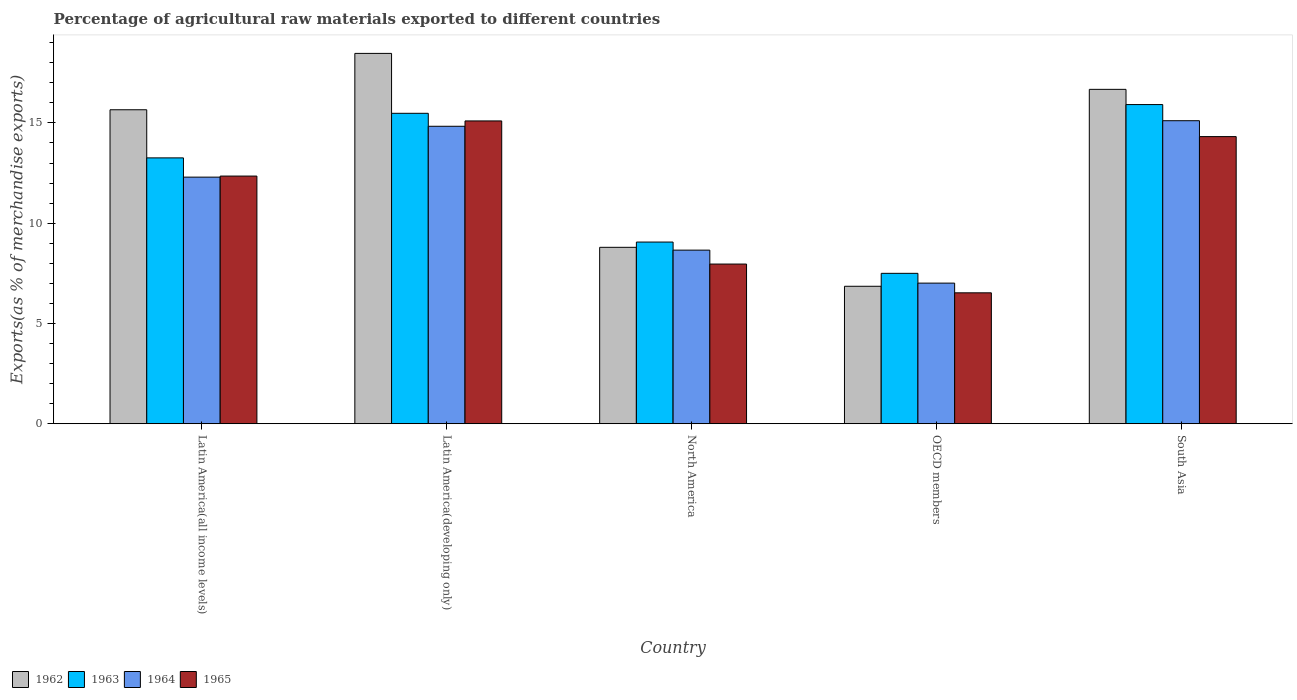How many different coloured bars are there?
Keep it short and to the point. 4. Are the number of bars per tick equal to the number of legend labels?
Your response must be concise. Yes. Are the number of bars on each tick of the X-axis equal?
Provide a succinct answer. Yes. How many bars are there on the 1st tick from the left?
Provide a succinct answer. 4. What is the label of the 2nd group of bars from the left?
Your answer should be very brief. Latin America(developing only). What is the percentage of exports to different countries in 1964 in OECD members?
Ensure brevity in your answer.  7.01. Across all countries, what is the maximum percentage of exports to different countries in 1964?
Offer a very short reply. 15.11. Across all countries, what is the minimum percentage of exports to different countries in 1965?
Your response must be concise. 6.53. In which country was the percentage of exports to different countries in 1964 maximum?
Provide a succinct answer. South Asia. In which country was the percentage of exports to different countries in 1963 minimum?
Provide a short and direct response. OECD members. What is the total percentage of exports to different countries in 1965 in the graph?
Ensure brevity in your answer.  56.26. What is the difference between the percentage of exports to different countries in 1965 in Latin America(developing only) and that in South Asia?
Make the answer very short. 0.78. What is the difference between the percentage of exports to different countries in 1965 in Latin America(all income levels) and the percentage of exports to different countries in 1964 in North America?
Your response must be concise. 3.69. What is the average percentage of exports to different countries in 1962 per country?
Make the answer very short. 13.29. What is the difference between the percentage of exports to different countries of/in 1965 and percentage of exports to different countries of/in 1964 in Latin America(all income levels)?
Your response must be concise. 0.05. In how many countries, is the percentage of exports to different countries in 1962 greater than 9 %?
Your answer should be very brief. 3. What is the ratio of the percentage of exports to different countries in 1965 in Latin America(all income levels) to that in South Asia?
Your answer should be very brief. 0.86. What is the difference between the highest and the second highest percentage of exports to different countries in 1964?
Keep it short and to the point. -2.54. What is the difference between the highest and the lowest percentage of exports to different countries in 1962?
Ensure brevity in your answer.  11.61. Is it the case that in every country, the sum of the percentage of exports to different countries in 1965 and percentage of exports to different countries in 1964 is greater than the sum of percentage of exports to different countries in 1962 and percentage of exports to different countries in 1963?
Offer a terse response. No. What does the 4th bar from the left in North America represents?
Ensure brevity in your answer.  1965. What does the 1st bar from the right in North America represents?
Offer a very short reply. 1965. Are all the bars in the graph horizontal?
Ensure brevity in your answer.  No. How many countries are there in the graph?
Keep it short and to the point. 5. Does the graph contain any zero values?
Your response must be concise. No. Does the graph contain grids?
Make the answer very short. No. How are the legend labels stacked?
Make the answer very short. Horizontal. What is the title of the graph?
Keep it short and to the point. Percentage of agricultural raw materials exported to different countries. What is the label or title of the X-axis?
Ensure brevity in your answer.  Country. What is the label or title of the Y-axis?
Your response must be concise. Exports(as % of merchandise exports). What is the Exports(as % of merchandise exports) in 1962 in Latin America(all income levels)?
Make the answer very short. 15.66. What is the Exports(as % of merchandise exports) of 1963 in Latin America(all income levels)?
Offer a very short reply. 13.26. What is the Exports(as % of merchandise exports) in 1964 in Latin America(all income levels)?
Ensure brevity in your answer.  12.3. What is the Exports(as % of merchandise exports) in 1965 in Latin America(all income levels)?
Make the answer very short. 12.35. What is the Exports(as % of merchandise exports) in 1962 in Latin America(developing only)?
Give a very brief answer. 18.47. What is the Exports(as % of merchandise exports) of 1963 in Latin America(developing only)?
Your response must be concise. 15.48. What is the Exports(as % of merchandise exports) of 1964 in Latin America(developing only)?
Give a very brief answer. 14.83. What is the Exports(as % of merchandise exports) in 1965 in Latin America(developing only)?
Offer a terse response. 15.1. What is the Exports(as % of merchandise exports) in 1962 in North America?
Provide a short and direct response. 8.8. What is the Exports(as % of merchandise exports) in 1963 in North America?
Provide a succinct answer. 9.06. What is the Exports(as % of merchandise exports) of 1964 in North America?
Provide a succinct answer. 8.66. What is the Exports(as % of merchandise exports) in 1965 in North America?
Your response must be concise. 7.96. What is the Exports(as % of merchandise exports) in 1962 in OECD members?
Make the answer very short. 6.85. What is the Exports(as % of merchandise exports) in 1963 in OECD members?
Provide a succinct answer. 7.5. What is the Exports(as % of merchandise exports) in 1964 in OECD members?
Your response must be concise. 7.01. What is the Exports(as % of merchandise exports) of 1965 in OECD members?
Give a very brief answer. 6.53. What is the Exports(as % of merchandise exports) of 1962 in South Asia?
Your response must be concise. 16.67. What is the Exports(as % of merchandise exports) in 1963 in South Asia?
Offer a terse response. 15.92. What is the Exports(as % of merchandise exports) of 1964 in South Asia?
Offer a terse response. 15.11. What is the Exports(as % of merchandise exports) in 1965 in South Asia?
Give a very brief answer. 14.32. Across all countries, what is the maximum Exports(as % of merchandise exports) in 1962?
Give a very brief answer. 18.47. Across all countries, what is the maximum Exports(as % of merchandise exports) of 1963?
Make the answer very short. 15.92. Across all countries, what is the maximum Exports(as % of merchandise exports) in 1964?
Offer a terse response. 15.11. Across all countries, what is the maximum Exports(as % of merchandise exports) of 1965?
Provide a short and direct response. 15.1. Across all countries, what is the minimum Exports(as % of merchandise exports) in 1962?
Provide a succinct answer. 6.85. Across all countries, what is the minimum Exports(as % of merchandise exports) of 1963?
Keep it short and to the point. 7.5. Across all countries, what is the minimum Exports(as % of merchandise exports) of 1964?
Your answer should be compact. 7.01. Across all countries, what is the minimum Exports(as % of merchandise exports) in 1965?
Ensure brevity in your answer.  6.53. What is the total Exports(as % of merchandise exports) of 1962 in the graph?
Offer a terse response. 66.45. What is the total Exports(as % of merchandise exports) in 1963 in the graph?
Offer a very short reply. 61.21. What is the total Exports(as % of merchandise exports) of 1964 in the graph?
Give a very brief answer. 57.91. What is the total Exports(as % of merchandise exports) of 1965 in the graph?
Make the answer very short. 56.26. What is the difference between the Exports(as % of merchandise exports) of 1962 in Latin America(all income levels) and that in Latin America(developing only)?
Give a very brief answer. -2.81. What is the difference between the Exports(as % of merchandise exports) of 1963 in Latin America(all income levels) and that in Latin America(developing only)?
Provide a succinct answer. -2.22. What is the difference between the Exports(as % of merchandise exports) of 1964 in Latin America(all income levels) and that in Latin America(developing only)?
Your response must be concise. -2.54. What is the difference between the Exports(as % of merchandise exports) of 1965 in Latin America(all income levels) and that in Latin America(developing only)?
Keep it short and to the point. -2.75. What is the difference between the Exports(as % of merchandise exports) in 1962 in Latin America(all income levels) and that in North America?
Provide a succinct answer. 6.86. What is the difference between the Exports(as % of merchandise exports) of 1963 in Latin America(all income levels) and that in North America?
Keep it short and to the point. 4.2. What is the difference between the Exports(as % of merchandise exports) of 1964 in Latin America(all income levels) and that in North America?
Keep it short and to the point. 3.64. What is the difference between the Exports(as % of merchandise exports) in 1965 in Latin America(all income levels) and that in North America?
Offer a terse response. 4.39. What is the difference between the Exports(as % of merchandise exports) of 1962 in Latin America(all income levels) and that in OECD members?
Ensure brevity in your answer.  8.8. What is the difference between the Exports(as % of merchandise exports) in 1963 in Latin America(all income levels) and that in OECD members?
Ensure brevity in your answer.  5.76. What is the difference between the Exports(as % of merchandise exports) in 1964 in Latin America(all income levels) and that in OECD members?
Your response must be concise. 5.29. What is the difference between the Exports(as % of merchandise exports) in 1965 in Latin America(all income levels) and that in OECD members?
Offer a very short reply. 5.82. What is the difference between the Exports(as % of merchandise exports) of 1962 in Latin America(all income levels) and that in South Asia?
Your answer should be very brief. -1.02. What is the difference between the Exports(as % of merchandise exports) of 1963 in Latin America(all income levels) and that in South Asia?
Provide a succinct answer. -2.66. What is the difference between the Exports(as % of merchandise exports) of 1964 in Latin America(all income levels) and that in South Asia?
Make the answer very short. -2.81. What is the difference between the Exports(as % of merchandise exports) of 1965 in Latin America(all income levels) and that in South Asia?
Offer a very short reply. -1.97. What is the difference between the Exports(as % of merchandise exports) in 1962 in Latin America(developing only) and that in North America?
Your response must be concise. 9.67. What is the difference between the Exports(as % of merchandise exports) of 1963 in Latin America(developing only) and that in North America?
Make the answer very short. 6.42. What is the difference between the Exports(as % of merchandise exports) of 1964 in Latin America(developing only) and that in North America?
Keep it short and to the point. 6.18. What is the difference between the Exports(as % of merchandise exports) of 1965 in Latin America(developing only) and that in North America?
Make the answer very short. 7.14. What is the difference between the Exports(as % of merchandise exports) in 1962 in Latin America(developing only) and that in OECD members?
Offer a very short reply. 11.61. What is the difference between the Exports(as % of merchandise exports) of 1963 in Latin America(developing only) and that in OECD members?
Ensure brevity in your answer.  7.98. What is the difference between the Exports(as % of merchandise exports) in 1964 in Latin America(developing only) and that in OECD members?
Ensure brevity in your answer.  7.82. What is the difference between the Exports(as % of merchandise exports) of 1965 in Latin America(developing only) and that in OECD members?
Provide a short and direct response. 8.57. What is the difference between the Exports(as % of merchandise exports) of 1962 in Latin America(developing only) and that in South Asia?
Make the answer very short. 1.79. What is the difference between the Exports(as % of merchandise exports) in 1963 in Latin America(developing only) and that in South Asia?
Your answer should be compact. -0.44. What is the difference between the Exports(as % of merchandise exports) of 1964 in Latin America(developing only) and that in South Asia?
Make the answer very short. -0.28. What is the difference between the Exports(as % of merchandise exports) in 1965 in Latin America(developing only) and that in South Asia?
Keep it short and to the point. 0.78. What is the difference between the Exports(as % of merchandise exports) in 1962 in North America and that in OECD members?
Your response must be concise. 1.94. What is the difference between the Exports(as % of merchandise exports) in 1963 in North America and that in OECD members?
Your answer should be compact. 1.56. What is the difference between the Exports(as % of merchandise exports) in 1964 in North America and that in OECD members?
Give a very brief answer. 1.65. What is the difference between the Exports(as % of merchandise exports) in 1965 in North America and that in OECD members?
Ensure brevity in your answer.  1.43. What is the difference between the Exports(as % of merchandise exports) of 1962 in North America and that in South Asia?
Keep it short and to the point. -7.88. What is the difference between the Exports(as % of merchandise exports) in 1963 in North America and that in South Asia?
Offer a very short reply. -6.86. What is the difference between the Exports(as % of merchandise exports) in 1964 in North America and that in South Asia?
Offer a terse response. -6.45. What is the difference between the Exports(as % of merchandise exports) of 1965 in North America and that in South Asia?
Your answer should be very brief. -6.36. What is the difference between the Exports(as % of merchandise exports) of 1962 in OECD members and that in South Asia?
Keep it short and to the point. -9.82. What is the difference between the Exports(as % of merchandise exports) of 1963 in OECD members and that in South Asia?
Your answer should be compact. -8.42. What is the difference between the Exports(as % of merchandise exports) in 1964 in OECD members and that in South Asia?
Give a very brief answer. -8.1. What is the difference between the Exports(as % of merchandise exports) of 1965 in OECD members and that in South Asia?
Keep it short and to the point. -7.79. What is the difference between the Exports(as % of merchandise exports) of 1962 in Latin America(all income levels) and the Exports(as % of merchandise exports) of 1963 in Latin America(developing only)?
Provide a succinct answer. 0.18. What is the difference between the Exports(as % of merchandise exports) of 1962 in Latin America(all income levels) and the Exports(as % of merchandise exports) of 1964 in Latin America(developing only)?
Make the answer very short. 0.82. What is the difference between the Exports(as % of merchandise exports) of 1962 in Latin America(all income levels) and the Exports(as % of merchandise exports) of 1965 in Latin America(developing only)?
Your answer should be very brief. 0.56. What is the difference between the Exports(as % of merchandise exports) of 1963 in Latin America(all income levels) and the Exports(as % of merchandise exports) of 1964 in Latin America(developing only)?
Make the answer very short. -1.58. What is the difference between the Exports(as % of merchandise exports) of 1963 in Latin America(all income levels) and the Exports(as % of merchandise exports) of 1965 in Latin America(developing only)?
Offer a terse response. -1.84. What is the difference between the Exports(as % of merchandise exports) in 1964 in Latin America(all income levels) and the Exports(as % of merchandise exports) in 1965 in Latin America(developing only)?
Provide a short and direct response. -2.8. What is the difference between the Exports(as % of merchandise exports) in 1962 in Latin America(all income levels) and the Exports(as % of merchandise exports) in 1963 in North America?
Ensure brevity in your answer.  6.6. What is the difference between the Exports(as % of merchandise exports) in 1962 in Latin America(all income levels) and the Exports(as % of merchandise exports) in 1964 in North America?
Offer a terse response. 7. What is the difference between the Exports(as % of merchandise exports) of 1962 in Latin America(all income levels) and the Exports(as % of merchandise exports) of 1965 in North America?
Provide a short and direct response. 7.69. What is the difference between the Exports(as % of merchandise exports) in 1963 in Latin America(all income levels) and the Exports(as % of merchandise exports) in 1965 in North America?
Your answer should be very brief. 5.29. What is the difference between the Exports(as % of merchandise exports) of 1964 in Latin America(all income levels) and the Exports(as % of merchandise exports) of 1965 in North America?
Give a very brief answer. 4.33. What is the difference between the Exports(as % of merchandise exports) in 1962 in Latin America(all income levels) and the Exports(as % of merchandise exports) in 1963 in OECD members?
Your answer should be compact. 8.16. What is the difference between the Exports(as % of merchandise exports) of 1962 in Latin America(all income levels) and the Exports(as % of merchandise exports) of 1964 in OECD members?
Provide a succinct answer. 8.65. What is the difference between the Exports(as % of merchandise exports) of 1962 in Latin America(all income levels) and the Exports(as % of merchandise exports) of 1965 in OECD members?
Your answer should be compact. 9.13. What is the difference between the Exports(as % of merchandise exports) in 1963 in Latin America(all income levels) and the Exports(as % of merchandise exports) in 1964 in OECD members?
Ensure brevity in your answer.  6.25. What is the difference between the Exports(as % of merchandise exports) of 1963 in Latin America(all income levels) and the Exports(as % of merchandise exports) of 1965 in OECD members?
Offer a very short reply. 6.73. What is the difference between the Exports(as % of merchandise exports) of 1964 in Latin America(all income levels) and the Exports(as % of merchandise exports) of 1965 in OECD members?
Offer a terse response. 5.77. What is the difference between the Exports(as % of merchandise exports) of 1962 in Latin America(all income levels) and the Exports(as % of merchandise exports) of 1963 in South Asia?
Your answer should be very brief. -0.26. What is the difference between the Exports(as % of merchandise exports) of 1962 in Latin America(all income levels) and the Exports(as % of merchandise exports) of 1964 in South Asia?
Make the answer very short. 0.55. What is the difference between the Exports(as % of merchandise exports) of 1962 in Latin America(all income levels) and the Exports(as % of merchandise exports) of 1965 in South Asia?
Provide a short and direct response. 1.34. What is the difference between the Exports(as % of merchandise exports) in 1963 in Latin America(all income levels) and the Exports(as % of merchandise exports) in 1964 in South Asia?
Make the answer very short. -1.85. What is the difference between the Exports(as % of merchandise exports) in 1963 in Latin America(all income levels) and the Exports(as % of merchandise exports) in 1965 in South Asia?
Provide a short and direct response. -1.06. What is the difference between the Exports(as % of merchandise exports) in 1964 in Latin America(all income levels) and the Exports(as % of merchandise exports) in 1965 in South Asia?
Offer a terse response. -2.02. What is the difference between the Exports(as % of merchandise exports) of 1962 in Latin America(developing only) and the Exports(as % of merchandise exports) of 1963 in North America?
Make the answer very short. 9.41. What is the difference between the Exports(as % of merchandise exports) in 1962 in Latin America(developing only) and the Exports(as % of merchandise exports) in 1964 in North America?
Your response must be concise. 9.81. What is the difference between the Exports(as % of merchandise exports) in 1962 in Latin America(developing only) and the Exports(as % of merchandise exports) in 1965 in North America?
Provide a succinct answer. 10.51. What is the difference between the Exports(as % of merchandise exports) in 1963 in Latin America(developing only) and the Exports(as % of merchandise exports) in 1964 in North America?
Offer a terse response. 6.82. What is the difference between the Exports(as % of merchandise exports) of 1963 in Latin America(developing only) and the Exports(as % of merchandise exports) of 1965 in North America?
Provide a short and direct response. 7.52. What is the difference between the Exports(as % of merchandise exports) of 1964 in Latin America(developing only) and the Exports(as % of merchandise exports) of 1965 in North America?
Your answer should be very brief. 6.87. What is the difference between the Exports(as % of merchandise exports) of 1962 in Latin America(developing only) and the Exports(as % of merchandise exports) of 1963 in OECD members?
Offer a very short reply. 10.97. What is the difference between the Exports(as % of merchandise exports) in 1962 in Latin America(developing only) and the Exports(as % of merchandise exports) in 1964 in OECD members?
Provide a short and direct response. 11.46. What is the difference between the Exports(as % of merchandise exports) in 1962 in Latin America(developing only) and the Exports(as % of merchandise exports) in 1965 in OECD members?
Your response must be concise. 11.94. What is the difference between the Exports(as % of merchandise exports) of 1963 in Latin America(developing only) and the Exports(as % of merchandise exports) of 1964 in OECD members?
Your response must be concise. 8.47. What is the difference between the Exports(as % of merchandise exports) in 1963 in Latin America(developing only) and the Exports(as % of merchandise exports) in 1965 in OECD members?
Provide a succinct answer. 8.95. What is the difference between the Exports(as % of merchandise exports) in 1964 in Latin America(developing only) and the Exports(as % of merchandise exports) in 1965 in OECD members?
Make the answer very short. 8.31. What is the difference between the Exports(as % of merchandise exports) in 1962 in Latin America(developing only) and the Exports(as % of merchandise exports) in 1963 in South Asia?
Provide a succinct answer. 2.55. What is the difference between the Exports(as % of merchandise exports) in 1962 in Latin America(developing only) and the Exports(as % of merchandise exports) in 1964 in South Asia?
Keep it short and to the point. 3.36. What is the difference between the Exports(as % of merchandise exports) in 1962 in Latin America(developing only) and the Exports(as % of merchandise exports) in 1965 in South Asia?
Offer a terse response. 4.15. What is the difference between the Exports(as % of merchandise exports) of 1963 in Latin America(developing only) and the Exports(as % of merchandise exports) of 1964 in South Asia?
Offer a terse response. 0.37. What is the difference between the Exports(as % of merchandise exports) of 1963 in Latin America(developing only) and the Exports(as % of merchandise exports) of 1965 in South Asia?
Your answer should be very brief. 1.16. What is the difference between the Exports(as % of merchandise exports) of 1964 in Latin America(developing only) and the Exports(as % of merchandise exports) of 1965 in South Asia?
Keep it short and to the point. 0.51. What is the difference between the Exports(as % of merchandise exports) of 1962 in North America and the Exports(as % of merchandise exports) of 1963 in OECD members?
Ensure brevity in your answer.  1.3. What is the difference between the Exports(as % of merchandise exports) of 1962 in North America and the Exports(as % of merchandise exports) of 1964 in OECD members?
Your answer should be very brief. 1.78. What is the difference between the Exports(as % of merchandise exports) of 1962 in North America and the Exports(as % of merchandise exports) of 1965 in OECD members?
Offer a very short reply. 2.27. What is the difference between the Exports(as % of merchandise exports) in 1963 in North America and the Exports(as % of merchandise exports) in 1964 in OECD members?
Give a very brief answer. 2.05. What is the difference between the Exports(as % of merchandise exports) in 1963 in North America and the Exports(as % of merchandise exports) in 1965 in OECD members?
Offer a terse response. 2.53. What is the difference between the Exports(as % of merchandise exports) of 1964 in North America and the Exports(as % of merchandise exports) of 1965 in OECD members?
Offer a terse response. 2.13. What is the difference between the Exports(as % of merchandise exports) of 1962 in North America and the Exports(as % of merchandise exports) of 1963 in South Asia?
Offer a terse response. -7.12. What is the difference between the Exports(as % of merchandise exports) in 1962 in North America and the Exports(as % of merchandise exports) in 1964 in South Asia?
Offer a terse response. -6.31. What is the difference between the Exports(as % of merchandise exports) in 1962 in North America and the Exports(as % of merchandise exports) in 1965 in South Asia?
Your response must be concise. -5.52. What is the difference between the Exports(as % of merchandise exports) of 1963 in North America and the Exports(as % of merchandise exports) of 1964 in South Asia?
Keep it short and to the point. -6.05. What is the difference between the Exports(as % of merchandise exports) in 1963 in North America and the Exports(as % of merchandise exports) in 1965 in South Asia?
Your response must be concise. -5.26. What is the difference between the Exports(as % of merchandise exports) in 1964 in North America and the Exports(as % of merchandise exports) in 1965 in South Asia?
Your response must be concise. -5.66. What is the difference between the Exports(as % of merchandise exports) of 1962 in OECD members and the Exports(as % of merchandise exports) of 1963 in South Asia?
Ensure brevity in your answer.  -9.06. What is the difference between the Exports(as % of merchandise exports) of 1962 in OECD members and the Exports(as % of merchandise exports) of 1964 in South Asia?
Provide a succinct answer. -8.26. What is the difference between the Exports(as % of merchandise exports) in 1962 in OECD members and the Exports(as % of merchandise exports) in 1965 in South Asia?
Your response must be concise. -7.46. What is the difference between the Exports(as % of merchandise exports) of 1963 in OECD members and the Exports(as % of merchandise exports) of 1964 in South Asia?
Offer a terse response. -7.61. What is the difference between the Exports(as % of merchandise exports) of 1963 in OECD members and the Exports(as % of merchandise exports) of 1965 in South Asia?
Ensure brevity in your answer.  -6.82. What is the difference between the Exports(as % of merchandise exports) in 1964 in OECD members and the Exports(as % of merchandise exports) in 1965 in South Asia?
Your response must be concise. -7.31. What is the average Exports(as % of merchandise exports) of 1962 per country?
Your answer should be very brief. 13.29. What is the average Exports(as % of merchandise exports) of 1963 per country?
Offer a terse response. 12.24. What is the average Exports(as % of merchandise exports) in 1964 per country?
Provide a succinct answer. 11.58. What is the average Exports(as % of merchandise exports) in 1965 per country?
Provide a succinct answer. 11.25. What is the difference between the Exports(as % of merchandise exports) in 1962 and Exports(as % of merchandise exports) in 1963 in Latin America(all income levels)?
Provide a succinct answer. 2.4. What is the difference between the Exports(as % of merchandise exports) of 1962 and Exports(as % of merchandise exports) of 1964 in Latin America(all income levels)?
Ensure brevity in your answer.  3.36. What is the difference between the Exports(as % of merchandise exports) in 1962 and Exports(as % of merchandise exports) in 1965 in Latin America(all income levels)?
Provide a short and direct response. 3.31. What is the difference between the Exports(as % of merchandise exports) in 1963 and Exports(as % of merchandise exports) in 1964 in Latin America(all income levels)?
Keep it short and to the point. 0.96. What is the difference between the Exports(as % of merchandise exports) in 1963 and Exports(as % of merchandise exports) in 1965 in Latin America(all income levels)?
Offer a very short reply. 0.91. What is the difference between the Exports(as % of merchandise exports) in 1964 and Exports(as % of merchandise exports) in 1965 in Latin America(all income levels)?
Ensure brevity in your answer.  -0.05. What is the difference between the Exports(as % of merchandise exports) of 1962 and Exports(as % of merchandise exports) of 1963 in Latin America(developing only)?
Provide a short and direct response. 2.99. What is the difference between the Exports(as % of merchandise exports) in 1962 and Exports(as % of merchandise exports) in 1964 in Latin America(developing only)?
Provide a succinct answer. 3.63. What is the difference between the Exports(as % of merchandise exports) in 1962 and Exports(as % of merchandise exports) in 1965 in Latin America(developing only)?
Ensure brevity in your answer.  3.37. What is the difference between the Exports(as % of merchandise exports) in 1963 and Exports(as % of merchandise exports) in 1964 in Latin America(developing only)?
Provide a succinct answer. 0.65. What is the difference between the Exports(as % of merchandise exports) of 1963 and Exports(as % of merchandise exports) of 1965 in Latin America(developing only)?
Your answer should be compact. 0.38. What is the difference between the Exports(as % of merchandise exports) of 1964 and Exports(as % of merchandise exports) of 1965 in Latin America(developing only)?
Offer a very short reply. -0.27. What is the difference between the Exports(as % of merchandise exports) in 1962 and Exports(as % of merchandise exports) in 1963 in North America?
Your response must be concise. -0.26. What is the difference between the Exports(as % of merchandise exports) of 1962 and Exports(as % of merchandise exports) of 1964 in North America?
Your response must be concise. 0.14. What is the difference between the Exports(as % of merchandise exports) of 1962 and Exports(as % of merchandise exports) of 1965 in North America?
Give a very brief answer. 0.83. What is the difference between the Exports(as % of merchandise exports) in 1963 and Exports(as % of merchandise exports) in 1964 in North America?
Give a very brief answer. 0.4. What is the difference between the Exports(as % of merchandise exports) of 1963 and Exports(as % of merchandise exports) of 1965 in North America?
Offer a terse response. 1.1. What is the difference between the Exports(as % of merchandise exports) in 1964 and Exports(as % of merchandise exports) in 1965 in North America?
Offer a very short reply. 0.69. What is the difference between the Exports(as % of merchandise exports) in 1962 and Exports(as % of merchandise exports) in 1963 in OECD members?
Offer a very short reply. -0.65. What is the difference between the Exports(as % of merchandise exports) in 1962 and Exports(as % of merchandise exports) in 1964 in OECD members?
Offer a terse response. -0.16. What is the difference between the Exports(as % of merchandise exports) in 1962 and Exports(as % of merchandise exports) in 1965 in OECD members?
Your answer should be compact. 0.33. What is the difference between the Exports(as % of merchandise exports) in 1963 and Exports(as % of merchandise exports) in 1964 in OECD members?
Make the answer very short. 0.49. What is the difference between the Exports(as % of merchandise exports) in 1963 and Exports(as % of merchandise exports) in 1965 in OECD members?
Offer a terse response. 0.97. What is the difference between the Exports(as % of merchandise exports) of 1964 and Exports(as % of merchandise exports) of 1965 in OECD members?
Offer a terse response. 0.48. What is the difference between the Exports(as % of merchandise exports) in 1962 and Exports(as % of merchandise exports) in 1963 in South Asia?
Your response must be concise. 0.76. What is the difference between the Exports(as % of merchandise exports) in 1962 and Exports(as % of merchandise exports) in 1964 in South Asia?
Keep it short and to the point. 1.56. What is the difference between the Exports(as % of merchandise exports) in 1962 and Exports(as % of merchandise exports) in 1965 in South Asia?
Provide a short and direct response. 2.36. What is the difference between the Exports(as % of merchandise exports) in 1963 and Exports(as % of merchandise exports) in 1964 in South Asia?
Your answer should be compact. 0.81. What is the difference between the Exports(as % of merchandise exports) in 1963 and Exports(as % of merchandise exports) in 1965 in South Asia?
Ensure brevity in your answer.  1.6. What is the difference between the Exports(as % of merchandise exports) in 1964 and Exports(as % of merchandise exports) in 1965 in South Asia?
Make the answer very short. 0.79. What is the ratio of the Exports(as % of merchandise exports) in 1962 in Latin America(all income levels) to that in Latin America(developing only)?
Your answer should be compact. 0.85. What is the ratio of the Exports(as % of merchandise exports) of 1963 in Latin America(all income levels) to that in Latin America(developing only)?
Your answer should be very brief. 0.86. What is the ratio of the Exports(as % of merchandise exports) of 1964 in Latin America(all income levels) to that in Latin America(developing only)?
Make the answer very short. 0.83. What is the ratio of the Exports(as % of merchandise exports) of 1965 in Latin America(all income levels) to that in Latin America(developing only)?
Make the answer very short. 0.82. What is the ratio of the Exports(as % of merchandise exports) of 1962 in Latin America(all income levels) to that in North America?
Provide a succinct answer. 1.78. What is the ratio of the Exports(as % of merchandise exports) in 1963 in Latin America(all income levels) to that in North America?
Provide a succinct answer. 1.46. What is the ratio of the Exports(as % of merchandise exports) of 1964 in Latin America(all income levels) to that in North America?
Offer a terse response. 1.42. What is the ratio of the Exports(as % of merchandise exports) in 1965 in Latin America(all income levels) to that in North America?
Keep it short and to the point. 1.55. What is the ratio of the Exports(as % of merchandise exports) of 1962 in Latin America(all income levels) to that in OECD members?
Offer a very short reply. 2.28. What is the ratio of the Exports(as % of merchandise exports) in 1963 in Latin America(all income levels) to that in OECD members?
Keep it short and to the point. 1.77. What is the ratio of the Exports(as % of merchandise exports) of 1964 in Latin America(all income levels) to that in OECD members?
Your answer should be very brief. 1.75. What is the ratio of the Exports(as % of merchandise exports) of 1965 in Latin America(all income levels) to that in OECD members?
Ensure brevity in your answer.  1.89. What is the ratio of the Exports(as % of merchandise exports) of 1962 in Latin America(all income levels) to that in South Asia?
Provide a succinct answer. 0.94. What is the ratio of the Exports(as % of merchandise exports) of 1963 in Latin America(all income levels) to that in South Asia?
Make the answer very short. 0.83. What is the ratio of the Exports(as % of merchandise exports) of 1964 in Latin America(all income levels) to that in South Asia?
Ensure brevity in your answer.  0.81. What is the ratio of the Exports(as % of merchandise exports) in 1965 in Latin America(all income levels) to that in South Asia?
Your answer should be compact. 0.86. What is the ratio of the Exports(as % of merchandise exports) in 1962 in Latin America(developing only) to that in North America?
Your answer should be compact. 2.1. What is the ratio of the Exports(as % of merchandise exports) in 1963 in Latin America(developing only) to that in North America?
Provide a short and direct response. 1.71. What is the ratio of the Exports(as % of merchandise exports) of 1964 in Latin America(developing only) to that in North America?
Make the answer very short. 1.71. What is the ratio of the Exports(as % of merchandise exports) in 1965 in Latin America(developing only) to that in North America?
Your answer should be compact. 1.9. What is the ratio of the Exports(as % of merchandise exports) in 1962 in Latin America(developing only) to that in OECD members?
Keep it short and to the point. 2.69. What is the ratio of the Exports(as % of merchandise exports) in 1963 in Latin America(developing only) to that in OECD members?
Offer a very short reply. 2.06. What is the ratio of the Exports(as % of merchandise exports) in 1964 in Latin America(developing only) to that in OECD members?
Offer a very short reply. 2.12. What is the ratio of the Exports(as % of merchandise exports) of 1965 in Latin America(developing only) to that in OECD members?
Your answer should be very brief. 2.31. What is the ratio of the Exports(as % of merchandise exports) of 1962 in Latin America(developing only) to that in South Asia?
Make the answer very short. 1.11. What is the ratio of the Exports(as % of merchandise exports) of 1963 in Latin America(developing only) to that in South Asia?
Provide a short and direct response. 0.97. What is the ratio of the Exports(as % of merchandise exports) in 1964 in Latin America(developing only) to that in South Asia?
Offer a very short reply. 0.98. What is the ratio of the Exports(as % of merchandise exports) of 1965 in Latin America(developing only) to that in South Asia?
Offer a very short reply. 1.05. What is the ratio of the Exports(as % of merchandise exports) in 1962 in North America to that in OECD members?
Keep it short and to the point. 1.28. What is the ratio of the Exports(as % of merchandise exports) of 1963 in North America to that in OECD members?
Ensure brevity in your answer.  1.21. What is the ratio of the Exports(as % of merchandise exports) in 1964 in North America to that in OECD members?
Your answer should be compact. 1.23. What is the ratio of the Exports(as % of merchandise exports) of 1965 in North America to that in OECD members?
Your response must be concise. 1.22. What is the ratio of the Exports(as % of merchandise exports) of 1962 in North America to that in South Asia?
Provide a short and direct response. 0.53. What is the ratio of the Exports(as % of merchandise exports) of 1963 in North America to that in South Asia?
Your answer should be very brief. 0.57. What is the ratio of the Exports(as % of merchandise exports) in 1964 in North America to that in South Asia?
Offer a terse response. 0.57. What is the ratio of the Exports(as % of merchandise exports) of 1965 in North America to that in South Asia?
Your answer should be compact. 0.56. What is the ratio of the Exports(as % of merchandise exports) of 1962 in OECD members to that in South Asia?
Your answer should be very brief. 0.41. What is the ratio of the Exports(as % of merchandise exports) in 1963 in OECD members to that in South Asia?
Keep it short and to the point. 0.47. What is the ratio of the Exports(as % of merchandise exports) of 1964 in OECD members to that in South Asia?
Your answer should be very brief. 0.46. What is the ratio of the Exports(as % of merchandise exports) in 1965 in OECD members to that in South Asia?
Keep it short and to the point. 0.46. What is the difference between the highest and the second highest Exports(as % of merchandise exports) in 1962?
Your response must be concise. 1.79. What is the difference between the highest and the second highest Exports(as % of merchandise exports) in 1963?
Your answer should be very brief. 0.44. What is the difference between the highest and the second highest Exports(as % of merchandise exports) in 1964?
Your answer should be compact. 0.28. What is the difference between the highest and the second highest Exports(as % of merchandise exports) in 1965?
Provide a succinct answer. 0.78. What is the difference between the highest and the lowest Exports(as % of merchandise exports) in 1962?
Make the answer very short. 11.61. What is the difference between the highest and the lowest Exports(as % of merchandise exports) of 1963?
Provide a short and direct response. 8.42. What is the difference between the highest and the lowest Exports(as % of merchandise exports) in 1964?
Your response must be concise. 8.1. What is the difference between the highest and the lowest Exports(as % of merchandise exports) in 1965?
Offer a very short reply. 8.57. 